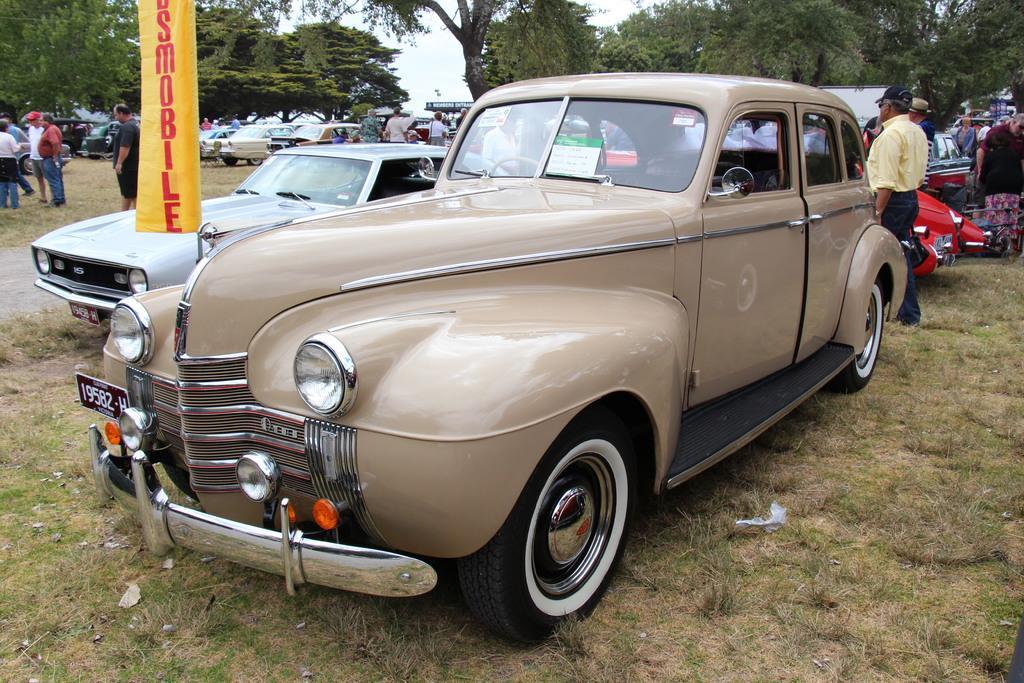Can you describe this image briefly? In this image there are cars and we can see people. At the bottom there is grass. In the background there are trees and sky. There is a board. 